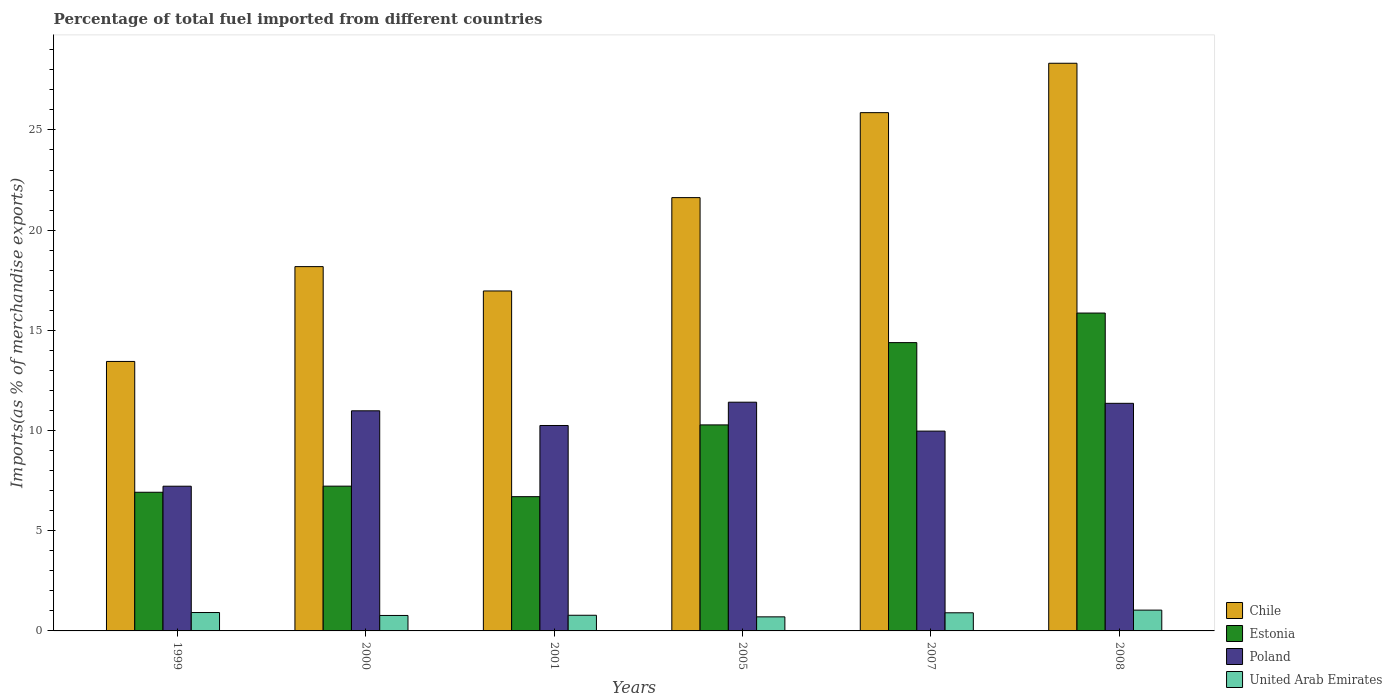Are the number of bars per tick equal to the number of legend labels?
Your answer should be compact. Yes. How many bars are there on the 6th tick from the left?
Ensure brevity in your answer.  4. How many bars are there on the 5th tick from the right?
Keep it short and to the point. 4. What is the percentage of imports to different countries in United Arab Emirates in 2007?
Your response must be concise. 0.91. Across all years, what is the maximum percentage of imports to different countries in Chile?
Give a very brief answer. 28.33. Across all years, what is the minimum percentage of imports to different countries in Chile?
Your answer should be compact. 13.45. In which year was the percentage of imports to different countries in Poland maximum?
Offer a terse response. 2005. What is the total percentage of imports to different countries in United Arab Emirates in the graph?
Your answer should be compact. 5.12. What is the difference between the percentage of imports to different countries in Poland in 2001 and that in 2007?
Your response must be concise. 0.28. What is the difference between the percentage of imports to different countries in Poland in 2007 and the percentage of imports to different countries in United Arab Emirates in 1999?
Make the answer very short. 9.05. What is the average percentage of imports to different countries in Estonia per year?
Make the answer very short. 10.23. In the year 2007, what is the difference between the percentage of imports to different countries in United Arab Emirates and percentage of imports to different countries in Chile?
Provide a succinct answer. -24.96. In how many years, is the percentage of imports to different countries in Chile greater than 7 %?
Offer a very short reply. 6. What is the ratio of the percentage of imports to different countries in Chile in 2001 to that in 2005?
Provide a short and direct response. 0.78. Is the percentage of imports to different countries in Poland in 2000 less than that in 2008?
Offer a very short reply. Yes. What is the difference between the highest and the second highest percentage of imports to different countries in United Arab Emirates?
Offer a terse response. 0.12. What is the difference between the highest and the lowest percentage of imports to different countries in Poland?
Make the answer very short. 4.19. In how many years, is the percentage of imports to different countries in Estonia greater than the average percentage of imports to different countries in Estonia taken over all years?
Your answer should be compact. 3. What does the 2nd bar from the left in 2008 represents?
Offer a terse response. Estonia. What does the 1st bar from the right in 2005 represents?
Keep it short and to the point. United Arab Emirates. Is it the case that in every year, the sum of the percentage of imports to different countries in Estonia and percentage of imports to different countries in Poland is greater than the percentage of imports to different countries in United Arab Emirates?
Provide a succinct answer. Yes. How many bars are there?
Give a very brief answer. 24. Are all the bars in the graph horizontal?
Your response must be concise. No. Does the graph contain any zero values?
Offer a very short reply. No. Does the graph contain grids?
Your answer should be very brief. No. Where does the legend appear in the graph?
Make the answer very short. Bottom right. How many legend labels are there?
Your response must be concise. 4. How are the legend labels stacked?
Make the answer very short. Vertical. What is the title of the graph?
Your answer should be compact. Percentage of total fuel imported from different countries. Does "Virgin Islands" appear as one of the legend labels in the graph?
Your answer should be compact. No. What is the label or title of the Y-axis?
Provide a succinct answer. Imports(as % of merchandise exports). What is the Imports(as % of merchandise exports) in Chile in 1999?
Your response must be concise. 13.45. What is the Imports(as % of merchandise exports) of Estonia in 1999?
Provide a short and direct response. 6.92. What is the Imports(as % of merchandise exports) of Poland in 1999?
Your answer should be compact. 7.22. What is the Imports(as % of merchandise exports) in United Arab Emirates in 1999?
Keep it short and to the point. 0.92. What is the Imports(as % of merchandise exports) of Chile in 2000?
Your answer should be compact. 18.18. What is the Imports(as % of merchandise exports) in Estonia in 2000?
Offer a very short reply. 7.22. What is the Imports(as % of merchandise exports) of Poland in 2000?
Ensure brevity in your answer.  10.98. What is the Imports(as % of merchandise exports) in United Arab Emirates in 2000?
Offer a very short reply. 0.77. What is the Imports(as % of merchandise exports) in Chile in 2001?
Give a very brief answer. 16.96. What is the Imports(as % of merchandise exports) of Estonia in 2001?
Offer a very short reply. 6.7. What is the Imports(as % of merchandise exports) in Poland in 2001?
Provide a short and direct response. 10.25. What is the Imports(as % of merchandise exports) in United Arab Emirates in 2001?
Offer a terse response. 0.78. What is the Imports(as % of merchandise exports) of Chile in 2005?
Your response must be concise. 21.62. What is the Imports(as % of merchandise exports) of Estonia in 2005?
Offer a terse response. 10.28. What is the Imports(as % of merchandise exports) of Poland in 2005?
Make the answer very short. 11.41. What is the Imports(as % of merchandise exports) in United Arab Emirates in 2005?
Your response must be concise. 0.7. What is the Imports(as % of merchandise exports) of Chile in 2007?
Offer a very short reply. 25.86. What is the Imports(as % of merchandise exports) of Estonia in 2007?
Keep it short and to the point. 14.39. What is the Imports(as % of merchandise exports) of Poland in 2007?
Offer a very short reply. 9.97. What is the Imports(as % of merchandise exports) of United Arab Emirates in 2007?
Provide a short and direct response. 0.91. What is the Imports(as % of merchandise exports) in Chile in 2008?
Provide a succinct answer. 28.33. What is the Imports(as % of merchandise exports) in Estonia in 2008?
Your answer should be compact. 15.86. What is the Imports(as % of merchandise exports) of Poland in 2008?
Your answer should be compact. 11.36. What is the Imports(as % of merchandise exports) in United Arab Emirates in 2008?
Ensure brevity in your answer.  1.04. Across all years, what is the maximum Imports(as % of merchandise exports) of Chile?
Your answer should be compact. 28.33. Across all years, what is the maximum Imports(as % of merchandise exports) of Estonia?
Offer a terse response. 15.86. Across all years, what is the maximum Imports(as % of merchandise exports) in Poland?
Provide a short and direct response. 11.41. Across all years, what is the maximum Imports(as % of merchandise exports) of United Arab Emirates?
Keep it short and to the point. 1.04. Across all years, what is the minimum Imports(as % of merchandise exports) in Chile?
Ensure brevity in your answer.  13.45. Across all years, what is the minimum Imports(as % of merchandise exports) in Estonia?
Make the answer very short. 6.7. Across all years, what is the minimum Imports(as % of merchandise exports) in Poland?
Make the answer very short. 7.22. Across all years, what is the minimum Imports(as % of merchandise exports) in United Arab Emirates?
Your response must be concise. 0.7. What is the total Imports(as % of merchandise exports) in Chile in the graph?
Keep it short and to the point. 124.4. What is the total Imports(as % of merchandise exports) of Estonia in the graph?
Provide a succinct answer. 61.37. What is the total Imports(as % of merchandise exports) of Poland in the graph?
Give a very brief answer. 61.2. What is the total Imports(as % of merchandise exports) of United Arab Emirates in the graph?
Your answer should be compact. 5.12. What is the difference between the Imports(as % of merchandise exports) of Chile in 1999 and that in 2000?
Your answer should be very brief. -4.73. What is the difference between the Imports(as % of merchandise exports) of Estonia in 1999 and that in 2000?
Your answer should be very brief. -0.3. What is the difference between the Imports(as % of merchandise exports) in Poland in 1999 and that in 2000?
Provide a succinct answer. -3.76. What is the difference between the Imports(as % of merchandise exports) in United Arab Emirates in 1999 and that in 2000?
Your response must be concise. 0.15. What is the difference between the Imports(as % of merchandise exports) of Chile in 1999 and that in 2001?
Give a very brief answer. -3.52. What is the difference between the Imports(as % of merchandise exports) in Estonia in 1999 and that in 2001?
Your answer should be compact. 0.22. What is the difference between the Imports(as % of merchandise exports) of Poland in 1999 and that in 2001?
Give a very brief answer. -3.03. What is the difference between the Imports(as % of merchandise exports) in United Arab Emirates in 1999 and that in 2001?
Make the answer very short. 0.14. What is the difference between the Imports(as % of merchandise exports) of Chile in 1999 and that in 2005?
Provide a succinct answer. -8.17. What is the difference between the Imports(as % of merchandise exports) in Estonia in 1999 and that in 2005?
Offer a very short reply. -3.36. What is the difference between the Imports(as % of merchandise exports) in Poland in 1999 and that in 2005?
Ensure brevity in your answer.  -4.19. What is the difference between the Imports(as % of merchandise exports) of United Arab Emirates in 1999 and that in 2005?
Provide a short and direct response. 0.22. What is the difference between the Imports(as % of merchandise exports) in Chile in 1999 and that in 2007?
Your response must be concise. -12.41. What is the difference between the Imports(as % of merchandise exports) of Estonia in 1999 and that in 2007?
Offer a terse response. -7.47. What is the difference between the Imports(as % of merchandise exports) in Poland in 1999 and that in 2007?
Give a very brief answer. -2.75. What is the difference between the Imports(as % of merchandise exports) in United Arab Emirates in 1999 and that in 2007?
Your answer should be very brief. 0.01. What is the difference between the Imports(as % of merchandise exports) in Chile in 1999 and that in 2008?
Make the answer very short. -14.88. What is the difference between the Imports(as % of merchandise exports) in Estonia in 1999 and that in 2008?
Offer a very short reply. -8.94. What is the difference between the Imports(as % of merchandise exports) in Poland in 1999 and that in 2008?
Give a very brief answer. -4.14. What is the difference between the Imports(as % of merchandise exports) of United Arab Emirates in 1999 and that in 2008?
Make the answer very short. -0.12. What is the difference between the Imports(as % of merchandise exports) in Chile in 2000 and that in 2001?
Make the answer very short. 1.22. What is the difference between the Imports(as % of merchandise exports) in Estonia in 2000 and that in 2001?
Ensure brevity in your answer.  0.52. What is the difference between the Imports(as % of merchandise exports) in Poland in 2000 and that in 2001?
Keep it short and to the point. 0.73. What is the difference between the Imports(as % of merchandise exports) in United Arab Emirates in 2000 and that in 2001?
Provide a succinct answer. -0.01. What is the difference between the Imports(as % of merchandise exports) in Chile in 2000 and that in 2005?
Your answer should be compact. -3.44. What is the difference between the Imports(as % of merchandise exports) in Estonia in 2000 and that in 2005?
Offer a terse response. -3.06. What is the difference between the Imports(as % of merchandise exports) of Poland in 2000 and that in 2005?
Your response must be concise. -0.43. What is the difference between the Imports(as % of merchandise exports) in United Arab Emirates in 2000 and that in 2005?
Your answer should be compact. 0.07. What is the difference between the Imports(as % of merchandise exports) in Chile in 2000 and that in 2007?
Ensure brevity in your answer.  -7.68. What is the difference between the Imports(as % of merchandise exports) of Estonia in 2000 and that in 2007?
Offer a terse response. -7.16. What is the difference between the Imports(as % of merchandise exports) in Poland in 2000 and that in 2007?
Make the answer very short. 1.01. What is the difference between the Imports(as % of merchandise exports) in United Arab Emirates in 2000 and that in 2007?
Your answer should be very brief. -0.13. What is the difference between the Imports(as % of merchandise exports) of Chile in 2000 and that in 2008?
Offer a very short reply. -10.15. What is the difference between the Imports(as % of merchandise exports) of Estonia in 2000 and that in 2008?
Your response must be concise. -8.64. What is the difference between the Imports(as % of merchandise exports) in Poland in 2000 and that in 2008?
Keep it short and to the point. -0.37. What is the difference between the Imports(as % of merchandise exports) in United Arab Emirates in 2000 and that in 2008?
Ensure brevity in your answer.  -0.27. What is the difference between the Imports(as % of merchandise exports) in Chile in 2001 and that in 2005?
Give a very brief answer. -4.66. What is the difference between the Imports(as % of merchandise exports) in Estonia in 2001 and that in 2005?
Ensure brevity in your answer.  -3.58. What is the difference between the Imports(as % of merchandise exports) of Poland in 2001 and that in 2005?
Provide a succinct answer. -1.16. What is the difference between the Imports(as % of merchandise exports) in United Arab Emirates in 2001 and that in 2005?
Make the answer very short. 0.08. What is the difference between the Imports(as % of merchandise exports) of Chile in 2001 and that in 2007?
Provide a short and direct response. -8.9. What is the difference between the Imports(as % of merchandise exports) in Estonia in 2001 and that in 2007?
Keep it short and to the point. -7.69. What is the difference between the Imports(as % of merchandise exports) in Poland in 2001 and that in 2007?
Your answer should be very brief. 0.28. What is the difference between the Imports(as % of merchandise exports) of United Arab Emirates in 2001 and that in 2007?
Keep it short and to the point. -0.12. What is the difference between the Imports(as % of merchandise exports) of Chile in 2001 and that in 2008?
Your answer should be very brief. -11.36. What is the difference between the Imports(as % of merchandise exports) of Estonia in 2001 and that in 2008?
Your answer should be very brief. -9.16. What is the difference between the Imports(as % of merchandise exports) of Poland in 2001 and that in 2008?
Keep it short and to the point. -1.11. What is the difference between the Imports(as % of merchandise exports) of United Arab Emirates in 2001 and that in 2008?
Your response must be concise. -0.26. What is the difference between the Imports(as % of merchandise exports) of Chile in 2005 and that in 2007?
Keep it short and to the point. -4.24. What is the difference between the Imports(as % of merchandise exports) in Estonia in 2005 and that in 2007?
Make the answer very short. -4.11. What is the difference between the Imports(as % of merchandise exports) of Poland in 2005 and that in 2007?
Keep it short and to the point. 1.44. What is the difference between the Imports(as % of merchandise exports) in United Arab Emirates in 2005 and that in 2007?
Provide a succinct answer. -0.2. What is the difference between the Imports(as % of merchandise exports) of Chile in 2005 and that in 2008?
Your answer should be compact. -6.7. What is the difference between the Imports(as % of merchandise exports) in Estonia in 2005 and that in 2008?
Your answer should be very brief. -5.58. What is the difference between the Imports(as % of merchandise exports) in Poland in 2005 and that in 2008?
Provide a short and direct response. 0.06. What is the difference between the Imports(as % of merchandise exports) of United Arab Emirates in 2005 and that in 2008?
Keep it short and to the point. -0.34. What is the difference between the Imports(as % of merchandise exports) of Chile in 2007 and that in 2008?
Your answer should be compact. -2.46. What is the difference between the Imports(as % of merchandise exports) in Estonia in 2007 and that in 2008?
Ensure brevity in your answer.  -1.48. What is the difference between the Imports(as % of merchandise exports) in Poland in 2007 and that in 2008?
Make the answer very short. -1.39. What is the difference between the Imports(as % of merchandise exports) in United Arab Emirates in 2007 and that in 2008?
Your answer should be compact. -0.13. What is the difference between the Imports(as % of merchandise exports) in Chile in 1999 and the Imports(as % of merchandise exports) in Estonia in 2000?
Your response must be concise. 6.22. What is the difference between the Imports(as % of merchandise exports) of Chile in 1999 and the Imports(as % of merchandise exports) of Poland in 2000?
Make the answer very short. 2.46. What is the difference between the Imports(as % of merchandise exports) in Chile in 1999 and the Imports(as % of merchandise exports) in United Arab Emirates in 2000?
Provide a succinct answer. 12.68. What is the difference between the Imports(as % of merchandise exports) in Estonia in 1999 and the Imports(as % of merchandise exports) in Poland in 2000?
Provide a succinct answer. -4.06. What is the difference between the Imports(as % of merchandise exports) of Estonia in 1999 and the Imports(as % of merchandise exports) of United Arab Emirates in 2000?
Your answer should be very brief. 6.15. What is the difference between the Imports(as % of merchandise exports) of Poland in 1999 and the Imports(as % of merchandise exports) of United Arab Emirates in 2000?
Offer a terse response. 6.45. What is the difference between the Imports(as % of merchandise exports) of Chile in 1999 and the Imports(as % of merchandise exports) of Estonia in 2001?
Your answer should be very brief. 6.75. What is the difference between the Imports(as % of merchandise exports) in Chile in 1999 and the Imports(as % of merchandise exports) in Poland in 2001?
Make the answer very short. 3.2. What is the difference between the Imports(as % of merchandise exports) of Chile in 1999 and the Imports(as % of merchandise exports) of United Arab Emirates in 2001?
Give a very brief answer. 12.67. What is the difference between the Imports(as % of merchandise exports) of Estonia in 1999 and the Imports(as % of merchandise exports) of Poland in 2001?
Provide a succinct answer. -3.33. What is the difference between the Imports(as % of merchandise exports) of Estonia in 1999 and the Imports(as % of merchandise exports) of United Arab Emirates in 2001?
Make the answer very short. 6.14. What is the difference between the Imports(as % of merchandise exports) of Poland in 1999 and the Imports(as % of merchandise exports) of United Arab Emirates in 2001?
Offer a terse response. 6.44. What is the difference between the Imports(as % of merchandise exports) in Chile in 1999 and the Imports(as % of merchandise exports) in Estonia in 2005?
Ensure brevity in your answer.  3.17. What is the difference between the Imports(as % of merchandise exports) of Chile in 1999 and the Imports(as % of merchandise exports) of Poland in 2005?
Provide a succinct answer. 2.03. What is the difference between the Imports(as % of merchandise exports) in Chile in 1999 and the Imports(as % of merchandise exports) in United Arab Emirates in 2005?
Your response must be concise. 12.75. What is the difference between the Imports(as % of merchandise exports) in Estonia in 1999 and the Imports(as % of merchandise exports) in Poland in 2005?
Keep it short and to the point. -4.49. What is the difference between the Imports(as % of merchandise exports) in Estonia in 1999 and the Imports(as % of merchandise exports) in United Arab Emirates in 2005?
Offer a very short reply. 6.22. What is the difference between the Imports(as % of merchandise exports) of Poland in 1999 and the Imports(as % of merchandise exports) of United Arab Emirates in 2005?
Your response must be concise. 6.52. What is the difference between the Imports(as % of merchandise exports) in Chile in 1999 and the Imports(as % of merchandise exports) in Estonia in 2007?
Make the answer very short. -0.94. What is the difference between the Imports(as % of merchandise exports) in Chile in 1999 and the Imports(as % of merchandise exports) in Poland in 2007?
Ensure brevity in your answer.  3.48. What is the difference between the Imports(as % of merchandise exports) of Chile in 1999 and the Imports(as % of merchandise exports) of United Arab Emirates in 2007?
Ensure brevity in your answer.  12.54. What is the difference between the Imports(as % of merchandise exports) of Estonia in 1999 and the Imports(as % of merchandise exports) of Poland in 2007?
Your response must be concise. -3.05. What is the difference between the Imports(as % of merchandise exports) in Estonia in 1999 and the Imports(as % of merchandise exports) in United Arab Emirates in 2007?
Keep it short and to the point. 6.01. What is the difference between the Imports(as % of merchandise exports) of Poland in 1999 and the Imports(as % of merchandise exports) of United Arab Emirates in 2007?
Ensure brevity in your answer.  6.32. What is the difference between the Imports(as % of merchandise exports) in Chile in 1999 and the Imports(as % of merchandise exports) in Estonia in 2008?
Provide a short and direct response. -2.41. What is the difference between the Imports(as % of merchandise exports) of Chile in 1999 and the Imports(as % of merchandise exports) of Poland in 2008?
Your response must be concise. 2.09. What is the difference between the Imports(as % of merchandise exports) in Chile in 1999 and the Imports(as % of merchandise exports) in United Arab Emirates in 2008?
Give a very brief answer. 12.41. What is the difference between the Imports(as % of merchandise exports) in Estonia in 1999 and the Imports(as % of merchandise exports) in Poland in 2008?
Give a very brief answer. -4.44. What is the difference between the Imports(as % of merchandise exports) of Estonia in 1999 and the Imports(as % of merchandise exports) of United Arab Emirates in 2008?
Provide a short and direct response. 5.88. What is the difference between the Imports(as % of merchandise exports) of Poland in 1999 and the Imports(as % of merchandise exports) of United Arab Emirates in 2008?
Offer a very short reply. 6.18. What is the difference between the Imports(as % of merchandise exports) of Chile in 2000 and the Imports(as % of merchandise exports) of Estonia in 2001?
Keep it short and to the point. 11.48. What is the difference between the Imports(as % of merchandise exports) in Chile in 2000 and the Imports(as % of merchandise exports) in Poland in 2001?
Your answer should be very brief. 7.93. What is the difference between the Imports(as % of merchandise exports) of Chile in 2000 and the Imports(as % of merchandise exports) of United Arab Emirates in 2001?
Your response must be concise. 17.4. What is the difference between the Imports(as % of merchandise exports) of Estonia in 2000 and the Imports(as % of merchandise exports) of Poland in 2001?
Provide a succinct answer. -3.03. What is the difference between the Imports(as % of merchandise exports) of Estonia in 2000 and the Imports(as % of merchandise exports) of United Arab Emirates in 2001?
Your response must be concise. 6.44. What is the difference between the Imports(as % of merchandise exports) of Poland in 2000 and the Imports(as % of merchandise exports) of United Arab Emirates in 2001?
Your response must be concise. 10.2. What is the difference between the Imports(as % of merchandise exports) of Chile in 2000 and the Imports(as % of merchandise exports) of Estonia in 2005?
Make the answer very short. 7.9. What is the difference between the Imports(as % of merchandise exports) in Chile in 2000 and the Imports(as % of merchandise exports) in Poland in 2005?
Provide a short and direct response. 6.77. What is the difference between the Imports(as % of merchandise exports) in Chile in 2000 and the Imports(as % of merchandise exports) in United Arab Emirates in 2005?
Provide a short and direct response. 17.48. What is the difference between the Imports(as % of merchandise exports) of Estonia in 2000 and the Imports(as % of merchandise exports) of Poland in 2005?
Make the answer very short. -4.19. What is the difference between the Imports(as % of merchandise exports) of Estonia in 2000 and the Imports(as % of merchandise exports) of United Arab Emirates in 2005?
Ensure brevity in your answer.  6.52. What is the difference between the Imports(as % of merchandise exports) in Poland in 2000 and the Imports(as % of merchandise exports) in United Arab Emirates in 2005?
Your answer should be compact. 10.28. What is the difference between the Imports(as % of merchandise exports) in Chile in 2000 and the Imports(as % of merchandise exports) in Estonia in 2007?
Offer a very short reply. 3.79. What is the difference between the Imports(as % of merchandise exports) of Chile in 2000 and the Imports(as % of merchandise exports) of Poland in 2007?
Your response must be concise. 8.21. What is the difference between the Imports(as % of merchandise exports) of Chile in 2000 and the Imports(as % of merchandise exports) of United Arab Emirates in 2007?
Your answer should be very brief. 17.27. What is the difference between the Imports(as % of merchandise exports) in Estonia in 2000 and the Imports(as % of merchandise exports) in Poland in 2007?
Offer a very short reply. -2.75. What is the difference between the Imports(as % of merchandise exports) of Estonia in 2000 and the Imports(as % of merchandise exports) of United Arab Emirates in 2007?
Your answer should be very brief. 6.32. What is the difference between the Imports(as % of merchandise exports) of Poland in 2000 and the Imports(as % of merchandise exports) of United Arab Emirates in 2007?
Keep it short and to the point. 10.08. What is the difference between the Imports(as % of merchandise exports) of Chile in 2000 and the Imports(as % of merchandise exports) of Estonia in 2008?
Provide a short and direct response. 2.32. What is the difference between the Imports(as % of merchandise exports) in Chile in 2000 and the Imports(as % of merchandise exports) in Poland in 2008?
Offer a terse response. 6.82. What is the difference between the Imports(as % of merchandise exports) in Chile in 2000 and the Imports(as % of merchandise exports) in United Arab Emirates in 2008?
Keep it short and to the point. 17.14. What is the difference between the Imports(as % of merchandise exports) of Estonia in 2000 and the Imports(as % of merchandise exports) of Poland in 2008?
Ensure brevity in your answer.  -4.13. What is the difference between the Imports(as % of merchandise exports) of Estonia in 2000 and the Imports(as % of merchandise exports) of United Arab Emirates in 2008?
Your response must be concise. 6.19. What is the difference between the Imports(as % of merchandise exports) in Poland in 2000 and the Imports(as % of merchandise exports) in United Arab Emirates in 2008?
Give a very brief answer. 9.95. What is the difference between the Imports(as % of merchandise exports) in Chile in 2001 and the Imports(as % of merchandise exports) in Estonia in 2005?
Make the answer very short. 6.68. What is the difference between the Imports(as % of merchandise exports) in Chile in 2001 and the Imports(as % of merchandise exports) in Poland in 2005?
Provide a short and direct response. 5.55. What is the difference between the Imports(as % of merchandise exports) of Chile in 2001 and the Imports(as % of merchandise exports) of United Arab Emirates in 2005?
Keep it short and to the point. 16.26. What is the difference between the Imports(as % of merchandise exports) of Estonia in 2001 and the Imports(as % of merchandise exports) of Poland in 2005?
Your response must be concise. -4.71. What is the difference between the Imports(as % of merchandise exports) of Estonia in 2001 and the Imports(as % of merchandise exports) of United Arab Emirates in 2005?
Your response must be concise. 6. What is the difference between the Imports(as % of merchandise exports) in Poland in 2001 and the Imports(as % of merchandise exports) in United Arab Emirates in 2005?
Make the answer very short. 9.55. What is the difference between the Imports(as % of merchandise exports) in Chile in 2001 and the Imports(as % of merchandise exports) in Estonia in 2007?
Your response must be concise. 2.58. What is the difference between the Imports(as % of merchandise exports) of Chile in 2001 and the Imports(as % of merchandise exports) of Poland in 2007?
Provide a succinct answer. 6.99. What is the difference between the Imports(as % of merchandise exports) of Chile in 2001 and the Imports(as % of merchandise exports) of United Arab Emirates in 2007?
Make the answer very short. 16.06. What is the difference between the Imports(as % of merchandise exports) of Estonia in 2001 and the Imports(as % of merchandise exports) of Poland in 2007?
Keep it short and to the point. -3.27. What is the difference between the Imports(as % of merchandise exports) of Estonia in 2001 and the Imports(as % of merchandise exports) of United Arab Emirates in 2007?
Your response must be concise. 5.79. What is the difference between the Imports(as % of merchandise exports) of Poland in 2001 and the Imports(as % of merchandise exports) of United Arab Emirates in 2007?
Keep it short and to the point. 9.35. What is the difference between the Imports(as % of merchandise exports) in Chile in 2001 and the Imports(as % of merchandise exports) in Estonia in 2008?
Make the answer very short. 1.1. What is the difference between the Imports(as % of merchandise exports) of Chile in 2001 and the Imports(as % of merchandise exports) of Poland in 2008?
Keep it short and to the point. 5.61. What is the difference between the Imports(as % of merchandise exports) in Chile in 2001 and the Imports(as % of merchandise exports) in United Arab Emirates in 2008?
Keep it short and to the point. 15.93. What is the difference between the Imports(as % of merchandise exports) in Estonia in 2001 and the Imports(as % of merchandise exports) in Poland in 2008?
Your answer should be very brief. -4.66. What is the difference between the Imports(as % of merchandise exports) in Estonia in 2001 and the Imports(as % of merchandise exports) in United Arab Emirates in 2008?
Make the answer very short. 5.66. What is the difference between the Imports(as % of merchandise exports) of Poland in 2001 and the Imports(as % of merchandise exports) of United Arab Emirates in 2008?
Your answer should be compact. 9.21. What is the difference between the Imports(as % of merchandise exports) of Chile in 2005 and the Imports(as % of merchandise exports) of Estonia in 2007?
Ensure brevity in your answer.  7.24. What is the difference between the Imports(as % of merchandise exports) of Chile in 2005 and the Imports(as % of merchandise exports) of Poland in 2007?
Provide a short and direct response. 11.65. What is the difference between the Imports(as % of merchandise exports) in Chile in 2005 and the Imports(as % of merchandise exports) in United Arab Emirates in 2007?
Your response must be concise. 20.72. What is the difference between the Imports(as % of merchandise exports) of Estonia in 2005 and the Imports(as % of merchandise exports) of Poland in 2007?
Make the answer very short. 0.31. What is the difference between the Imports(as % of merchandise exports) in Estonia in 2005 and the Imports(as % of merchandise exports) in United Arab Emirates in 2007?
Ensure brevity in your answer.  9.38. What is the difference between the Imports(as % of merchandise exports) of Poland in 2005 and the Imports(as % of merchandise exports) of United Arab Emirates in 2007?
Provide a succinct answer. 10.51. What is the difference between the Imports(as % of merchandise exports) in Chile in 2005 and the Imports(as % of merchandise exports) in Estonia in 2008?
Give a very brief answer. 5.76. What is the difference between the Imports(as % of merchandise exports) of Chile in 2005 and the Imports(as % of merchandise exports) of Poland in 2008?
Provide a succinct answer. 10.26. What is the difference between the Imports(as % of merchandise exports) of Chile in 2005 and the Imports(as % of merchandise exports) of United Arab Emirates in 2008?
Your answer should be very brief. 20.58. What is the difference between the Imports(as % of merchandise exports) in Estonia in 2005 and the Imports(as % of merchandise exports) in Poland in 2008?
Offer a very short reply. -1.08. What is the difference between the Imports(as % of merchandise exports) in Estonia in 2005 and the Imports(as % of merchandise exports) in United Arab Emirates in 2008?
Ensure brevity in your answer.  9.24. What is the difference between the Imports(as % of merchandise exports) in Poland in 2005 and the Imports(as % of merchandise exports) in United Arab Emirates in 2008?
Your answer should be very brief. 10.38. What is the difference between the Imports(as % of merchandise exports) of Chile in 2007 and the Imports(as % of merchandise exports) of Estonia in 2008?
Offer a terse response. 10. What is the difference between the Imports(as % of merchandise exports) of Chile in 2007 and the Imports(as % of merchandise exports) of Poland in 2008?
Offer a very short reply. 14.5. What is the difference between the Imports(as % of merchandise exports) of Chile in 2007 and the Imports(as % of merchandise exports) of United Arab Emirates in 2008?
Your answer should be very brief. 24.82. What is the difference between the Imports(as % of merchandise exports) of Estonia in 2007 and the Imports(as % of merchandise exports) of Poland in 2008?
Offer a very short reply. 3.03. What is the difference between the Imports(as % of merchandise exports) in Estonia in 2007 and the Imports(as % of merchandise exports) in United Arab Emirates in 2008?
Your answer should be compact. 13.35. What is the difference between the Imports(as % of merchandise exports) in Poland in 2007 and the Imports(as % of merchandise exports) in United Arab Emirates in 2008?
Offer a terse response. 8.93. What is the average Imports(as % of merchandise exports) of Chile per year?
Provide a short and direct response. 20.73. What is the average Imports(as % of merchandise exports) of Estonia per year?
Your answer should be very brief. 10.23. What is the average Imports(as % of merchandise exports) of Poland per year?
Make the answer very short. 10.2. What is the average Imports(as % of merchandise exports) in United Arab Emirates per year?
Your answer should be very brief. 0.85. In the year 1999, what is the difference between the Imports(as % of merchandise exports) of Chile and Imports(as % of merchandise exports) of Estonia?
Make the answer very short. 6.53. In the year 1999, what is the difference between the Imports(as % of merchandise exports) of Chile and Imports(as % of merchandise exports) of Poland?
Give a very brief answer. 6.23. In the year 1999, what is the difference between the Imports(as % of merchandise exports) in Chile and Imports(as % of merchandise exports) in United Arab Emirates?
Make the answer very short. 12.53. In the year 1999, what is the difference between the Imports(as % of merchandise exports) of Estonia and Imports(as % of merchandise exports) of Poland?
Offer a terse response. -0.3. In the year 1999, what is the difference between the Imports(as % of merchandise exports) in Estonia and Imports(as % of merchandise exports) in United Arab Emirates?
Your answer should be compact. 6. In the year 1999, what is the difference between the Imports(as % of merchandise exports) in Poland and Imports(as % of merchandise exports) in United Arab Emirates?
Offer a terse response. 6.3. In the year 2000, what is the difference between the Imports(as % of merchandise exports) in Chile and Imports(as % of merchandise exports) in Estonia?
Ensure brevity in your answer.  10.96. In the year 2000, what is the difference between the Imports(as % of merchandise exports) in Chile and Imports(as % of merchandise exports) in Poland?
Ensure brevity in your answer.  7.2. In the year 2000, what is the difference between the Imports(as % of merchandise exports) of Chile and Imports(as % of merchandise exports) of United Arab Emirates?
Ensure brevity in your answer.  17.41. In the year 2000, what is the difference between the Imports(as % of merchandise exports) of Estonia and Imports(as % of merchandise exports) of Poland?
Your response must be concise. -3.76. In the year 2000, what is the difference between the Imports(as % of merchandise exports) in Estonia and Imports(as % of merchandise exports) in United Arab Emirates?
Make the answer very short. 6.45. In the year 2000, what is the difference between the Imports(as % of merchandise exports) in Poland and Imports(as % of merchandise exports) in United Arab Emirates?
Provide a short and direct response. 10.21. In the year 2001, what is the difference between the Imports(as % of merchandise exports) of Chile and Imports(as % of merchandise exports) of Estonia?
Offer a terse response. 10.26. In the year 2001, what is the difference between the Imports(as % of merchandise exports) of Chile and Imports(as % of merchandise exports) of Poland?
Give a very brief answer. 6.71. In the year 2001, what is the difference between the Imports(as % of merchandise exports) of Chile and Imports(as % of merchandise exports) of United Arab Emirates?
Ensure brevity in your answer.  16.18. In the year 2001, what is the difference between the Imports(as % of merchandise exports) in Estonia and Imports(as % of merchandise exports) in Poland?
Keep it short and to the point. -3.55. In the year 2001, what is the difference between the Imports(as % of merchandise exports) of Estonia and Imports(as % of merchandise exports) of United Arab Emirates?
Provide a succinct answer. 5.92. In the year 2001, what is the difference between the Imports(as % of merchandise exports) in Poland and Imports(as % of merchandise exports) in United Arab Emirates?
Your answer should be compact. 9.47. In the year 2005, what is the difference between the Imports(as % of merchandise exports) of Chile and Imports(as % of merchandise exports) of Estonia?
Your answer should be compact. 11.34. In the year 2005, what is the difference between the Imports(as % of merchandise exports) of Chile and Imports(as % of merchandise exports) of Poland?
Your response must be concise. 10.21. In the year 2005, what is the difference between the Imports(as % of merchandise exports) of Chile and Imports(as % of merchandise exports) of United Arab Emirates?
Keep it short and to the point. 20.92. In the year 2005, what is the difference between the Imports(as % of merchandise exports) of Estonia and Imports(as % of merchandise exports) of Poland?
Your response must be concise. -1.13. In the year 2005, what is the difference between the Imports(as % of merchandise exports) of Estonia and Imports(as % of merchandise exports) of United Arab Emirates?
Provide a succinct answer. 9.58. In the year 2005, what is the difference between the Imports(as % of merchandise exports) of Poland and Imports(as % of merchandise exports) of United Arab Emirates?
Offer a very short reply. 10.71. In the year 2007, what is the difference between the Imports(as % of merchandise exports) in Chile and Imports(as % of merchandise exports) in Estonia?
Provide a short and direct response. 11.48. In the year 2007, what is the difference between the Imports(as % of merchandise exports) in Chile and Imports(as % of merchandise exports) in Poland?
Your answer should be compact. 15.89. In the year 2007, what is the difference between the Imports(as % of merchandise exports) in Chile and Imports(as % of merchandise exports) in United Arab Emirates?
Give a very brief answer. 24.96. In the year 2007, what is the difference between the Imports(as % of merchandise exports) in Estonia and Imports(as % of merchandise exports) in Poland?
Offer a terse response. 4.42. In the year 2007, what is the difference between the Imports(as % of merchandise exports) in Estonia and Imports(as % of merchandise exports) in United Arab Emirates?
Your response must be concise. 13.48. In the year 2007, what is the difference between the Imports(as % of merchandise exports) of Poland and Imports(as % of merchandise exports) of United Arab Emirates?
Make the answer very short. 9.07. In the year 2008, what is the difference between the Imports(as % of merchandise exports) of Chile and Imports(as % of merchandise exports) of Estonia?
Your answer should be compact. 12.47. In the year 2008, what is the difference between the Imports(as % of merchandise exports) in Chile and Imports(as % of merchandise exports) in Poland?
Offer a very short reply. 16.97. In the year 2008, what is the difference between the Imports(as % of merchandise exports) in Chile and Imports(as % of merchandise exports) in United Arab Emirates?
Keep it short and to the point. 27.29. In the year 2008, what is the difference between the Imports(as % of merchandise exports) of Estonia and Imports(as % of merchandise exports) of Poland?
Keep it short and to the point. 4.5. In the year 2008, what is the difference between the Imports(as % of merchandise exports) in Estonia and Imports(as % of merchandise exports) in United Arab Emirates?
Your response must be concise. 14.82. In the year 2008, what is the difference between the Imports(as % of merchandise exports) of Poland and Imports(as % of merchandise exports) of United Arab Emirates?
Make the answer very short. 10.32. What is the ratio of the Imports(as % of merchandise exports) of Chile in 1999 to that in 2000?
Offer a terse response. 0.74. What is the ratio of the Imports(as % of merchandise exports) of Estonia in 1999 to that in 2000?
Your answer should be compact. 0.96. What is the ratio of the Imports(as % of merchandise exports) in Poland in 1999 to that in 2000?
Ensure brevity in your answer.  0.66. What is the ratio of the Imports(as % of merchandise exports) in United Arab Emirates in 1999 to that in 2000?
Make the answer very short. 1.19. What is the ratio of the Imports(as % of merchandise exports) of Chile in 1999 to that in 2001?
Provide a short and direct response. 0.79. What is the ratio of the Imports(as % of merchandise exports) in Estonia in 1999 to that in 2001?
Offer a very short reply. 1.03. What is the ratio of the Imports(as % of merchandise exports) of Poland in 1999 to that in 2001?
Offer a very short reply. 0.7. What is the ratio of the Imports(as % of merchandise exports) in United Arab Emirates in 1999 to that in 2001?
Make the answer very short. 1.18. What is the ratio of the Imports(as % of merchandise exports) in Chile in 1999 to that in 2005?
Offer a terse response. 0.62. What is the ratio of the Imports(as % of merchandise exports) in Estonia in 1999 to that in 2005?
Give a very brief answer. 0.67. What is the ratio of the Imports(as % of merchandise exports) of Poland in 1999 to that in 2005?
Your answer should be compact. 0.63. What is the ratio of the Imports(as % of merchandise exports) of United Arab Emirates in 1999 to that in 2005?
Offer a very short reply. 1.31. What is the ratio of the Imports(as % of merchandise exports) in Chile in 1999 to that in 2007?
Ensure brevity in your answer.  0.52. What is the ratio of the Imports(as % of merchandise exports) in Estonia in 1999 to that in 2007?
Make the answer very short. 0.48. What is the ratio of the Imports(as % of merchandise exports) of Poland in 1999 to that in 2007?
Provide a succinct answer. 0.72. What is the ratio of the Imports(as % of merchandise exports) in United Arab Emirates in 1999 to that in 2007?
Keep it short and to the point. 1.01. What is the ratio of the Imports(as % of merchandise exports) in Chile in 1999 to that in 2008?
Offer a very short reply. 0.47. What is the ratio of the Imports(as % of merchandise exports) of Estonia in 1999 to that in 2008?
Give a very brief answer. 0.44. What is the ratio of the Imports(as % of merchandise exports) of Poland in 1999 to that in 2008?
Keep it short and to the point. 0.64. What is the ratio of the Imports(as % of merchandise exports) in United Arab Emirates in 1999 to that in 2008?
Provide a short and direct response. 0.88. What is the ratio of the Imports(as % of merchandise exports) in Chile in 2000 to that in 2001?
Make the answer very short. 1.07. What is the ratio of the Imports(as % of merchandise exports) in Estonia in 2000 to that in 2001?
Your answer should be compact. 1.08. What is the ratio of the Imports(as % of merchandise exports) of Poland in 2000 to that in 2001?
Provide a short and direct response. 1.07. What is the ratio of the Imports(as % of merchandise exports) in United Arab Emirates in 2000 to that in 2001?
Your response must be concise. 0.99. What is the ratio of the Imports(as % of merchandise exports) of Chile in 2000 to that in 2005?
Give a very brief answer. 0.84. What is the ratio of the Imports(as % of merchandise exports) in Estonia in 2000 to that in 2005?
Make the answer very short. 0.7. What is the ratio of the Imports(as % of merchandise exports) of Poland in 2000 to that in 2005?
Your answer should be very brief. 0.96. What is the ratio of the Imports(as % of merchandise exports) in United Arab Emirates in 2000 to that in 2005?
Your answer should be compact. 1.1. What is the ratio of the Imports(as % of merchandise exports) in Chile in 2000 to that in 2007?
Give a very brief answer. 0.7. What is the ratio of the Imports(as % of merchandise exports) in Estonia in 2000 to that in 2007?
Ensure brevity in your answer.  0.5. What is the ratio of the Imports(as % of merchandise exports) of Poland in 2000 to that in 2007?
Make the answer very short. 1.1. What is the ratio of the Imports(as % of merchandise exports) of United Arab Emirates in 2000 to that in 2007?
Make the answer very short. 0.85. What is the ratio of the Imports(as % of merchandise exports) in Chile in 2000 to that in 2008?
Offer a terse response. 0.64. What is the ratio of the Imports(as % of merchandise exports) of Estonia in 2000 to that in 2008?
Give a very brief answer. 0.46. What is the ratio of the Imports(as % of merchandise exports) of Poland in 2000 to that in 2008?
Provide a short and direct response. 0.97. What is the ratio of the Imports(as % of merchandise exports) in United Arab Emirates in 2000 to that in 2008?
Make the answer very short. 0.74. What is the ratio of the Imports(as % of merchandise exports) of Chile in 2001 to that in 2005?
Provide a short and direct response. 0.78. What is the ratio of the Imports(as % of merchandise exports) of Estonia in 2001 to that in 2005?
Your response must be concise. 0.65. What is the ratio of the Imports(as % of merchandise exports) in Poland in 2001 to that in 2005?
Keep it short and to the point. 0.9. What is the ratio of the Imports(as % of merchandise exports) in United Arab Emirates in 2001 to that in 2005?
Your answer should be very brief. 1.11. What is the ratio of the Imports(as % of merchandise exports) of Chile in 2001 to that in 2007?
Your response must be concise. 0.66. What is the ratio of the Imports(as % of merchandise exports) in Estonia in 2001 to that in 2007?
Keep it short and to the point. 0.47. What is the ratio of the Imports(as % of merchandise exports) in Poland in 2001 to that in 2007?
Your response must be concise. 1.03. What is the ratio of the Imports(as % of merchandise exports) in United Arab Emirates in 2001 to that in 2007?
Provide a succinct answer. 0.86. What is the ratio of the Imports(as % of merchandise exports) of Chile in 2001 to that in 2008?
Offer a very short reply. 0.6. What is the ratio of the Imports(as % of merchandise exports) of Estonia in 2001 to that in 2008?
Offer a terse response. 0.42. What is the ratio of the Imports(as % of merchandise exports) in Poland in 2001 to that in 2008?
Provide a succinct answer. 0.9. What is the ratio of the Imports(as % of merchandise exports) of United Arab Emirates in 2001 to that in 2008?
Give a very brief answer. 0.75. What is the ratio of the Imports(as % of merchandise exports) of Chile in 2005 to that in 2007?
Ensure brevity in your answer.  0.84. What is the ratio of the Imports(as % of merchandise exports) of Estonia in 2005 to that in 2007?
Your answer should be compact. 0.71. What is the ratio of the Imports(as % of merchandise exports) of Poland in 2005 to that in 2007?
Keep it short and to the point. 1.14. What is the ratio of the Imports(as % of merchandise exports) in United Arab Emirates in 2005 to that in 2007?
Make the answer very short. 0.78. What is the ratio of the Imports(as % of merchandise exports) of Chile in 2005 to that in 2008?
Your response must be concise. 0.76. What is the ratio of the Imports(as % of merchandise exports) of Estonia in 2005 to that in 2008?
Give a very brief answer. 0.65. What is the ratio of the Imports(as % of merchandise exports) of Poland in 2005 to that in 2008?
Provide a succinct answer. 1. What is the ratio of the Imports(as % of merchandise exports) of United Arab Emirates in 2005 to that in 2008?
Your answer should be very brief. 0.68. What is the ratio of the Imports(as % of merchandise exports) of Estonia in 2007 to that in 2008?
Ensure brevity in your answer.  0.91. What is the ratio of the Imports(as % of merchandise exports) of Poland in 2007 to that in 2008?
Provide a succinct answer. 0.88. What is the ratio of the Imports(as % of merchandise exports) of United Arab Emirates in 2007 to that in 2008?
Offer a terse response. 0.87. What is the difference between the highest and the second highest Imports(as % of merchandise exports) in Chile?
Ensure brevity in your answer.  2.46. What is the difference between the highest and the second highest Imports(as % of merchandise exports) of Estonia?
Offer a very short reply. 1.48. What is the difference between the highest and the second highest Imports(as % of merchandise exports) of Poland?
Provide a succinct answer. 0.06. What is the difference between the highest and the second highest Imports(as % of merchandise exports) of United Arab Emirates?
Your answer should be compact. 0.12. What is the difference between the highest and the lowest Imports(as % of merchandise exports) in Chile?
Your answer should be compact. 14.88. What is the difference between the highest and the lowest Imports(as % of merchandise exports) in Estonia?
Offer a very short reply. 9.16. What is the difference between the highest and the lowest Imports(as % of merchandise exports) of Poland?
Ensure brevity in your answer.  4.19. What is the difference between the highest and the lowest Imports(as % of merchandise exports) in United Arab Emirates?
Offer a terse response. 0.34. 